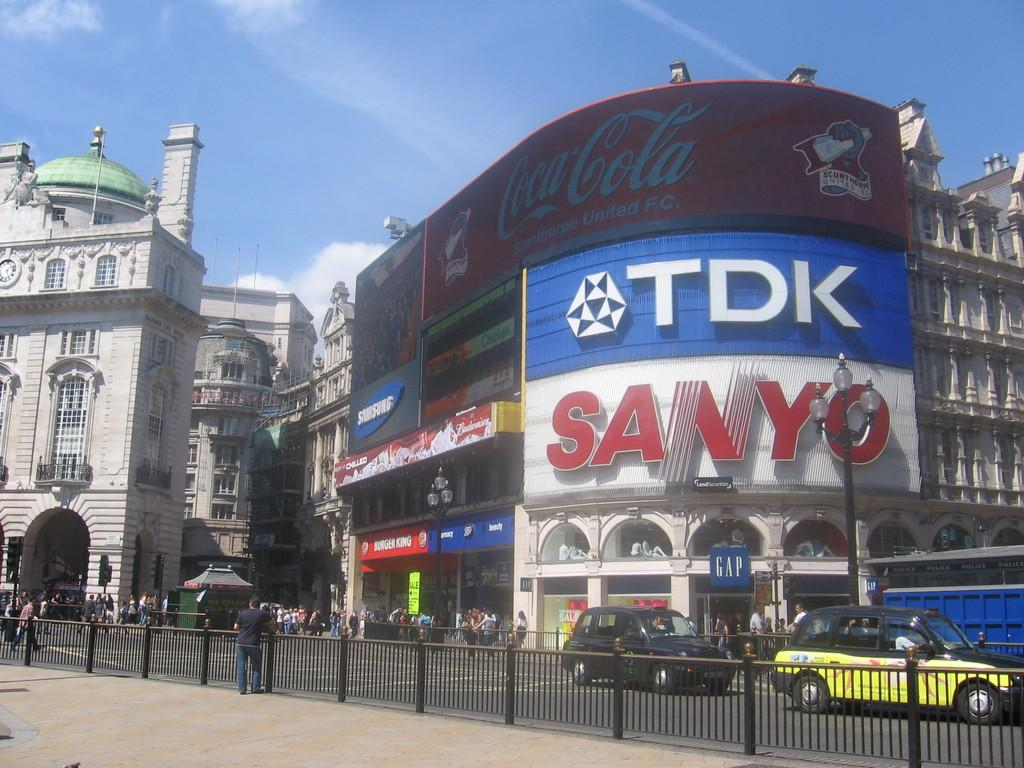Provide a one-sentence caption for the provided image. Located in a city, we see a wall full of advertisments including Coca Cola, Tdk and Sanyo, the street is busy. 